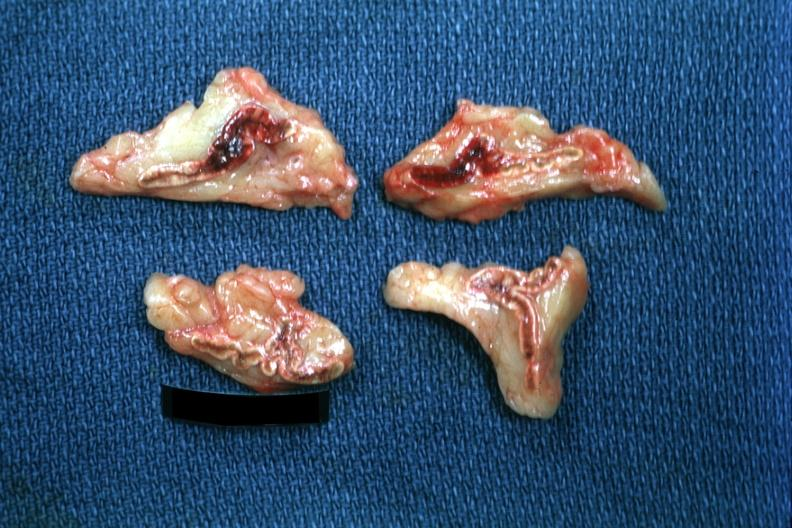what is present?
Answer the question using a single word or phrase. Endocrine 